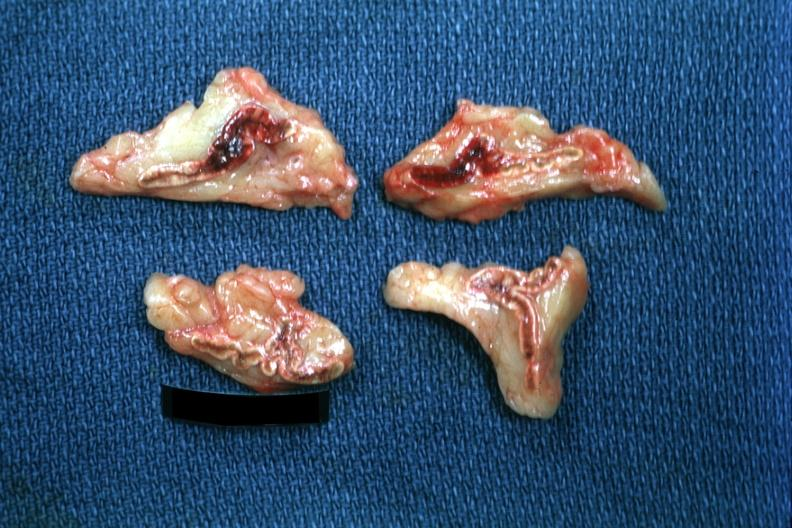what is present?
Answer the question using a single word or phrase. Endocrine 